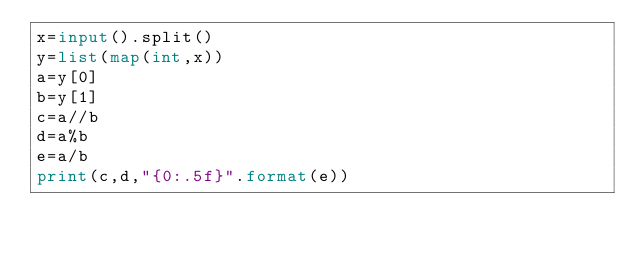<code> <loc_0><loc_0><loc_500><loc_500><_Python_>x=input().split()
y=list(map(int,x))
a=y[0]
b=y[1]
c=a//b
d=a%b
e=a/b
print(c,d,"{0:.5f}".format(e))
</code> 